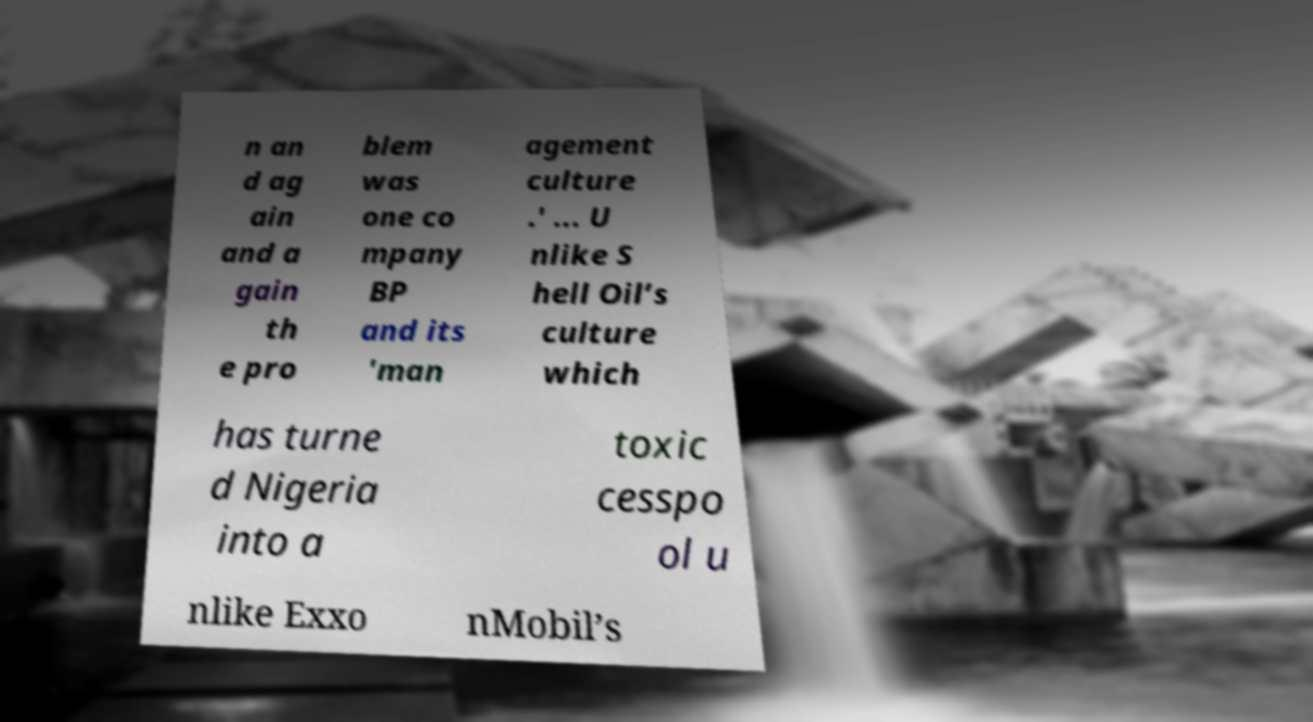For documentation purposes, I need the text within this image transcribed. Could you provide that? n an d ag ain and a gain th e pro blem was one co mpany BP and its 'man agement culture .' ... U nlike S hell Oil’s culture which has turne d Nigeria into a toxic cesspo ol u nlike Exxo nMobil’s 